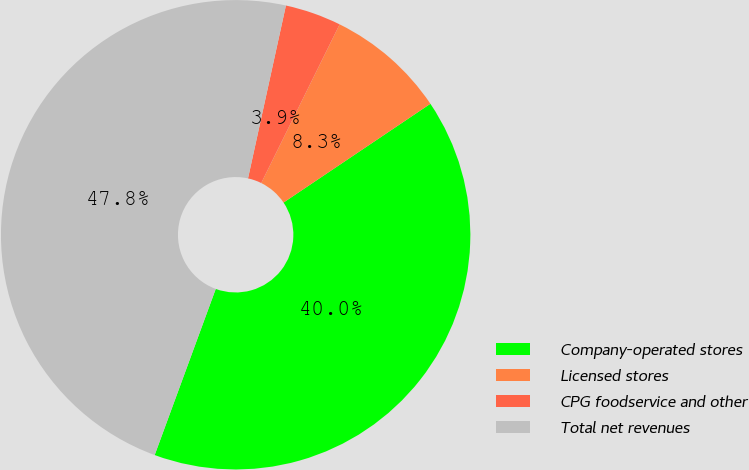Convert chart. <chart><loc_0><loc_0><loc_500><loc_500><pie_chart><fcel>Company-operated stores<fcel>Licensed stores<fcel>CPG foodservice and other<fcel>Total net revenues<nl><fcel>40.03%<fcel>8.27%<fcel>3.87%<fcel>47.83%<nl></chart> 